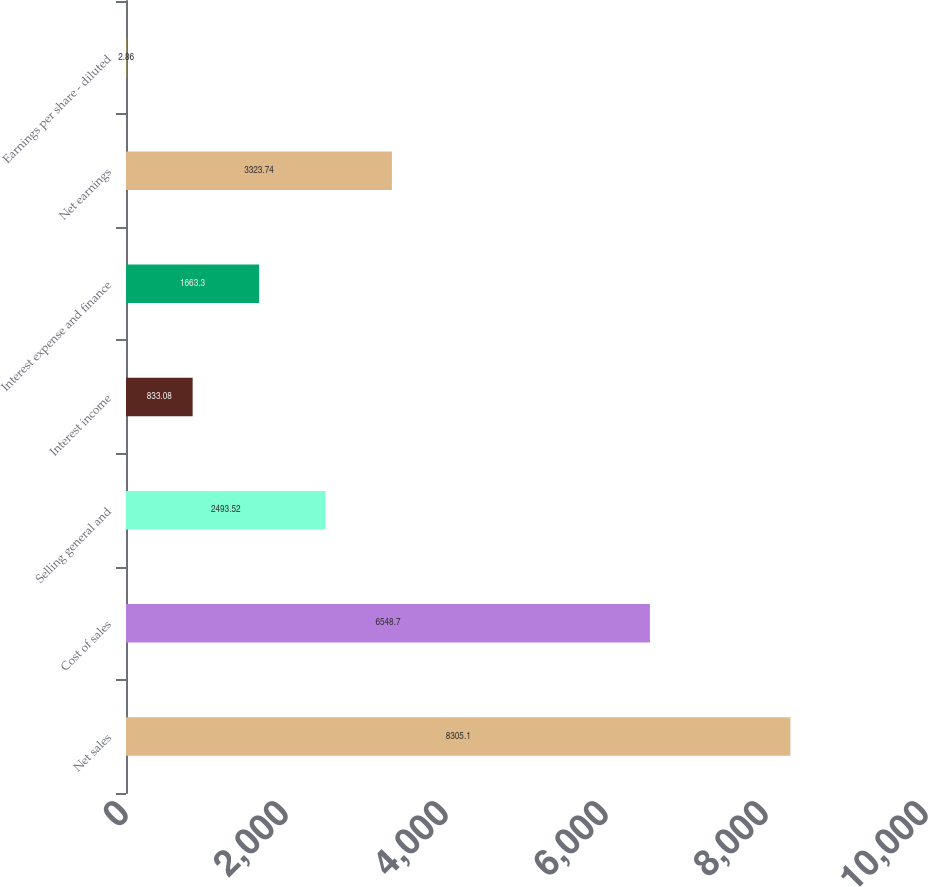Convert chart to OTSL. <chart><loc_0><loc_0><loc_500><loc_500><bar_chart><fcel>Net sales<fcel>Cost of sales<fcel>Selling general and<fcel>Interest income<fcel>Interest expense and finance<fcel>Net earnings<fcel>Earnings per share - diluted<nl><fcel>8305.1<fcel>6548.7<fcel>2493.52<fcel>833.08<fcel>1663.3<fcel>3323.74<fcel>2.86<nl></chart> 